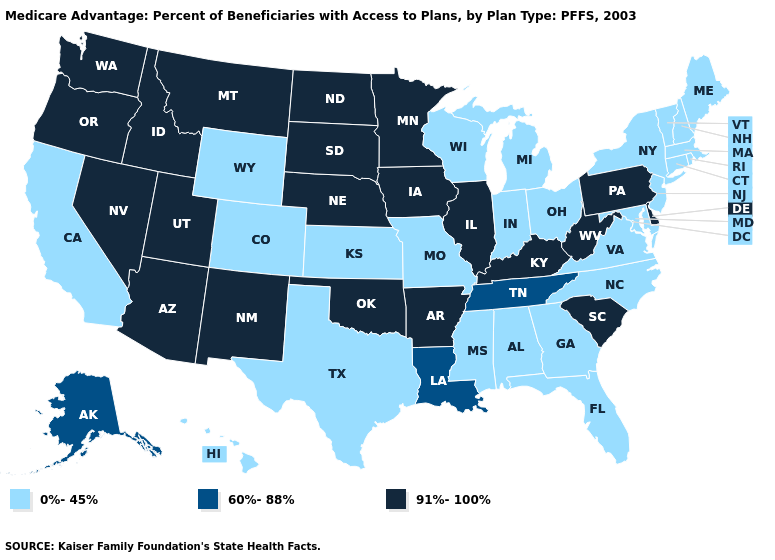Name the states that have a value in the range 91%-100%?
Concise answer only. Arkansas, Arizona, Delaware, Iowa, Idaho, Illinois, Kentucky, Minnesota, Montana, North Dakota, Nebraska, New Mexico, Nevada, Oklahoma, Oregon, Pennsylvania, South Carolina, South Dakota, Utah, Washington, West Virginia. Among the states that border North Carolina , does South Carolina have the lowest value?
Write a very short answer. No. Name the states that have a value in the range 0%-45%?
Be succinct. Alabama, California, Colorado, Connecticut, Florida, Georgia, Hawaii, Indiana, Kansas, Massachusetts, Maryland, Maine, Michigan, Missouri, Mississippi, North Carolina, New Hampshire, New Jersey, New York, Ohio, Rhode Island, Texas, Virginia, Vermont, Wisconsin, Wyoming. What is the value of Idaho?
Short answer required. 91%-100%. Among the states that border Wyoming , which have the highest value?
Be succinct. Idaho, Montana, Nebraska, South Dakota, Utah. Does the first symbol in the legend represent the smallest category?
Keep it brief. Yes. What is the value of Mississippi?
Answer briefly. 0%-45%. What is the value of Michigan?
Quick response, please. 0%-45%. What is the highest value in the MidWest ?
Short answer required. 91%-100%. Which states hav the highest value in the Northeast?
Give a very brief answer. Pennsylvania. What is the value of Michigan?
Short answer required. 0%-45%. Is the legend a continuous bar?
Concise answer only. No. What is the highest value in the USA?
Keep it brief. 91%-100%. Name the states that have a value in the range 91%-100%?
Concise answer only. Arkansas, Arizona, Delaware, Iowa, Idaho, Illinois, Kentucky, Minnesota, Montana, North Dakota, Nebraska, New Mexico, Nevada, Oklahoma, Oregon, Pennsylvania, South Carolina, South Dakota, Utah, Washington, West Virginia. Does the first symbol in the legend represent the smallest category?
Keep it brief. Yes. 